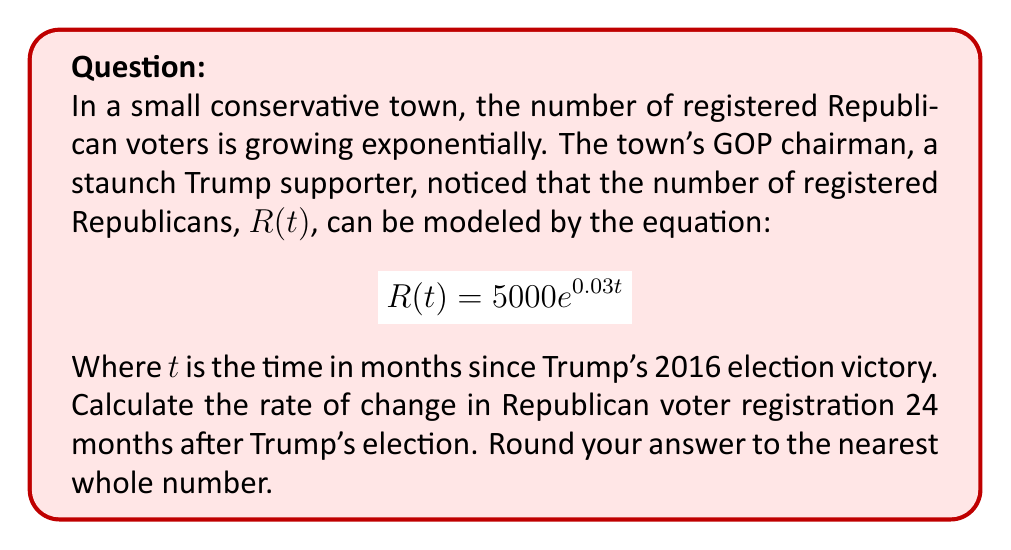Could you help me with this problem? To solve this problem, we need to find the derivative of the given function and evaluate it at $t = 24$. Here's the step-by-step process:

1) The given function is $R(t) = 5000e^{0.03t}$

2) To find the rate of change, we need to differentiate $R(t)$ with respect to $t$:
   
   $$\frac{dR}{dt} = 5000 \cdot 0.03 \cdot e^{0.03t} = 150e^{0.03t}$$

3) This derivative represents the instantaneous rate of change of Republican voter registration at any time $t$.

4) To find the rate of change 24 months after Trump's election, we substitute $t = 24$ into our derivative:

   $$\frac{dR}{dt}|_{t=24} = 150e^{0.03(24)} = 150e^{0.72}$$

5) Calculate this value:
   
   $$150e^{0.72} \approx 150 \cdot 2.0544 \approx 308.16$$

6) Rounding to the nearest whole number:

   $$308.16 \approx 308$$

Therefore, 24 months after Trump's election, the Republican voter registration in this town was increasing at a rate of approximately 308 voters per month.
Answer: 308 voters per month 